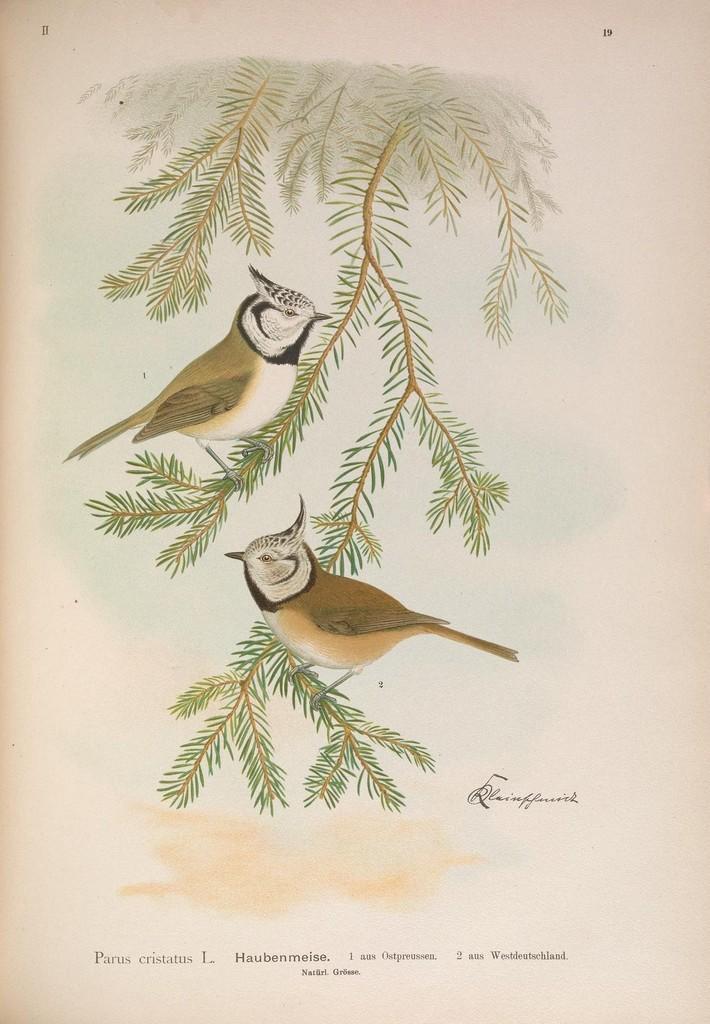In one or two sentences, can you explain what this image depicts? In this image I can see a poster and in the poster I can see a tree which is green and brown in color and on the tree I can see two birds which are white, black, cream and brown in color. I can see the cream colored background. 